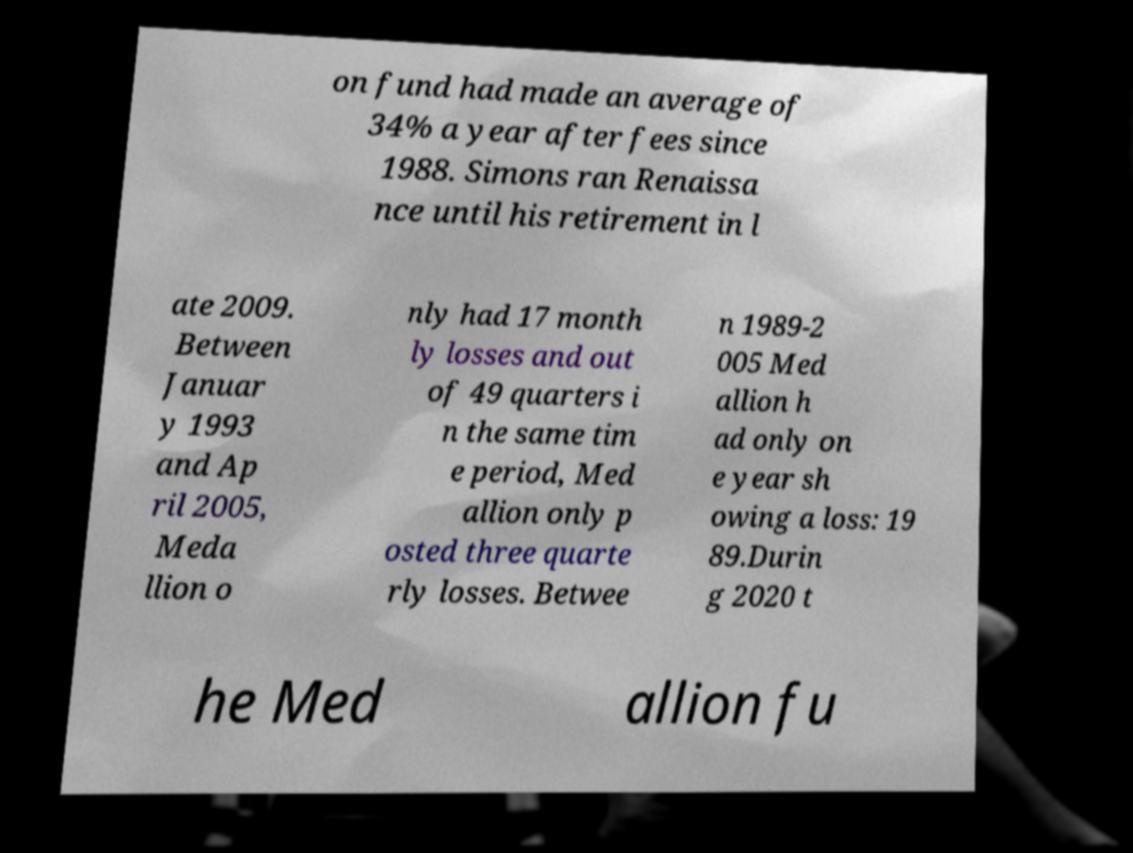What messages or text are displayed in this image? I need them in a readable, typed format. on fund had made an average of 34% a year after fees since 1988. Simons ran Renaissa nce until his retirement in l ate 2009. Between Januar y 1993 and Ap ril 2005, Meda llion o nly had 17 month ly losses and out of 49 quarters i n the same tim e period, Med allion only p osted three quarte rly losses. Betwee n 1989-2 005 Med allion h ad only on e year sh owing a loss: 19 89.Durin g 2020 t he Med allion fu 